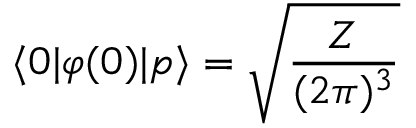<formula> <loc_0><loc_0><loc_500><loc_500>\langle 0 | \varphi ( 0 ) | p \rangle = { \sqrt { \frac { Z } { ( 2 \pi ) ^ { 3 } } } }</formula> 